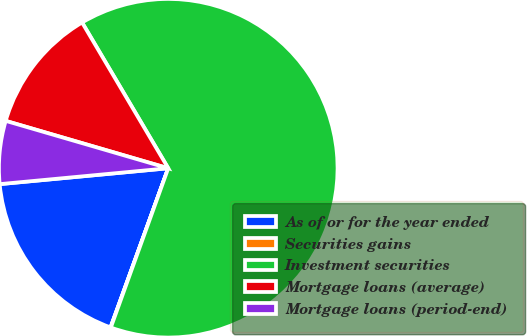Convert chart. <chart><loc_0><loc_0><loc_500><loc_500><pie_chart><fcel>As of or for the year ended<fcel>Securities gains<fcel>Investment securities<fcel>Mortgage loans (average)<fcel>Mortgage loans (period-end)<nl><fcel>17.97%<fcel>0.03%<fcel>64.01%<fcel>11.99%<fcel>6.01%<nl></chart> 